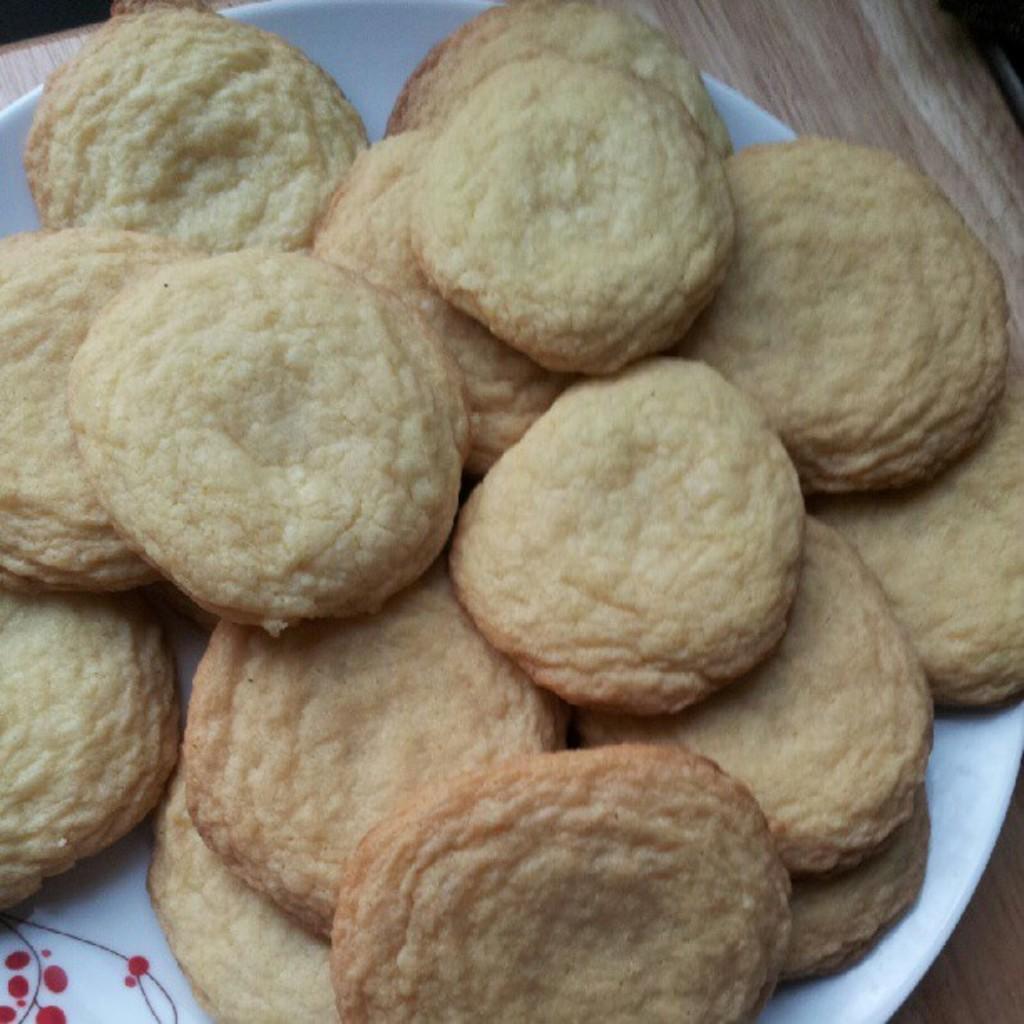Could you give a brief overview of what you see in this image? This image consists of cookies kept on a plate. The plate is kept on a table. 